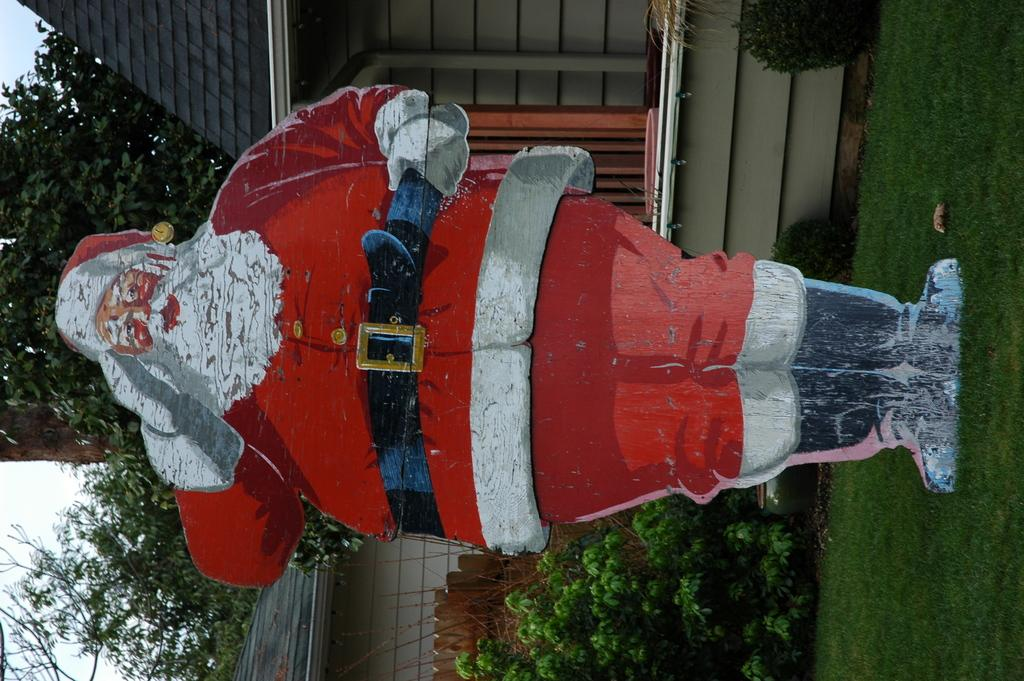What is the main subject on the ground in the image? There is a large cutout of Santa Claus on the ground. What type of surface is the Santa Claus cutout placed on? There is grass on the ground. What can be seen in the background of the image? There are plants, houses, and trees in the background of the image. What is visible above the background elements? The sky is visible in the background of the image. What type of lace is being used to decorate the bread in the image? There is no bread or lace present in the image; it features a large cutout of Santa Claus on the ground with grass and background elements. 